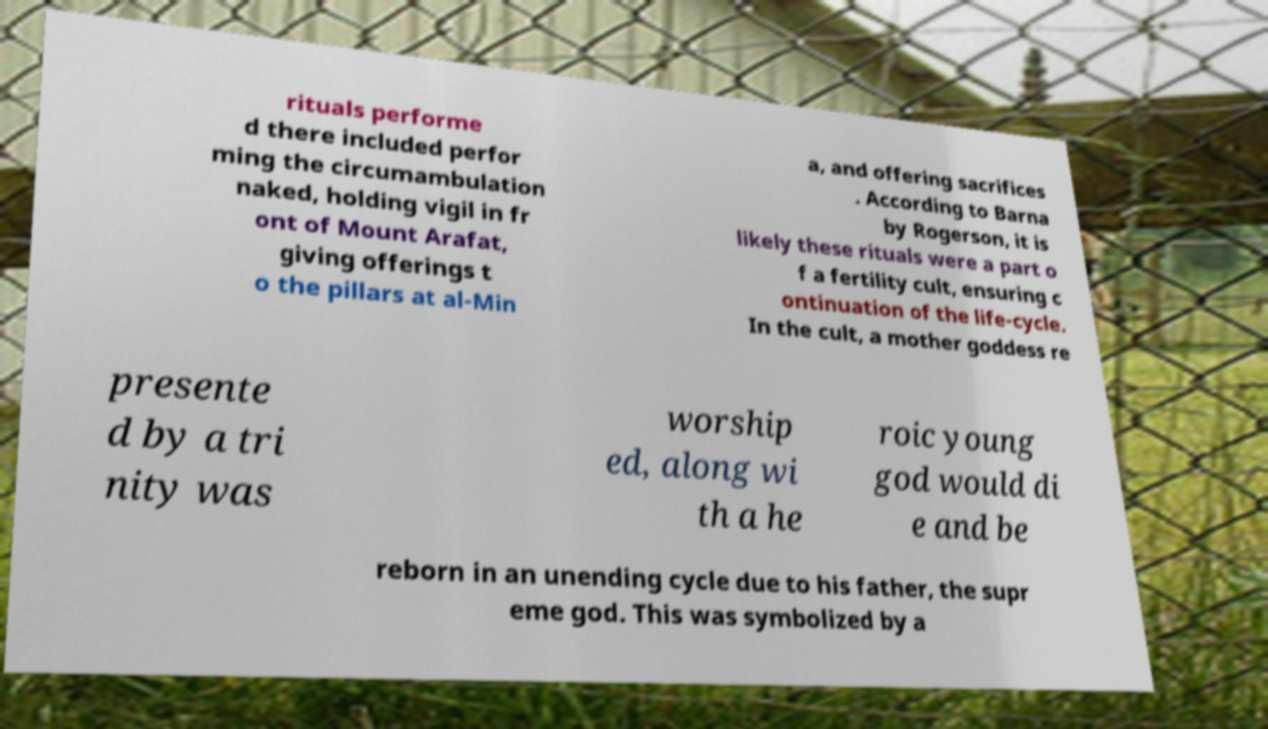I need the written content from this picture converted into text. Can you do that? rituals performe d there included perfor ming the circumambulation naked, holding vigil in fr ont of Mount Arafat, giving offerings t o the pillars at al-Min a, and offering sacrifices . According to Barna by Rogerson, it is likely these rituals were a part o f a fertility cult, ensuring c ontinuation of the life-cycle. In the cult, a mother goddess re presente d by a tri nity was worship ed, along wi th a he roic young god would di e and be reborn in an unending cycle due to his father, the supr eme god. This was symbolized by a 